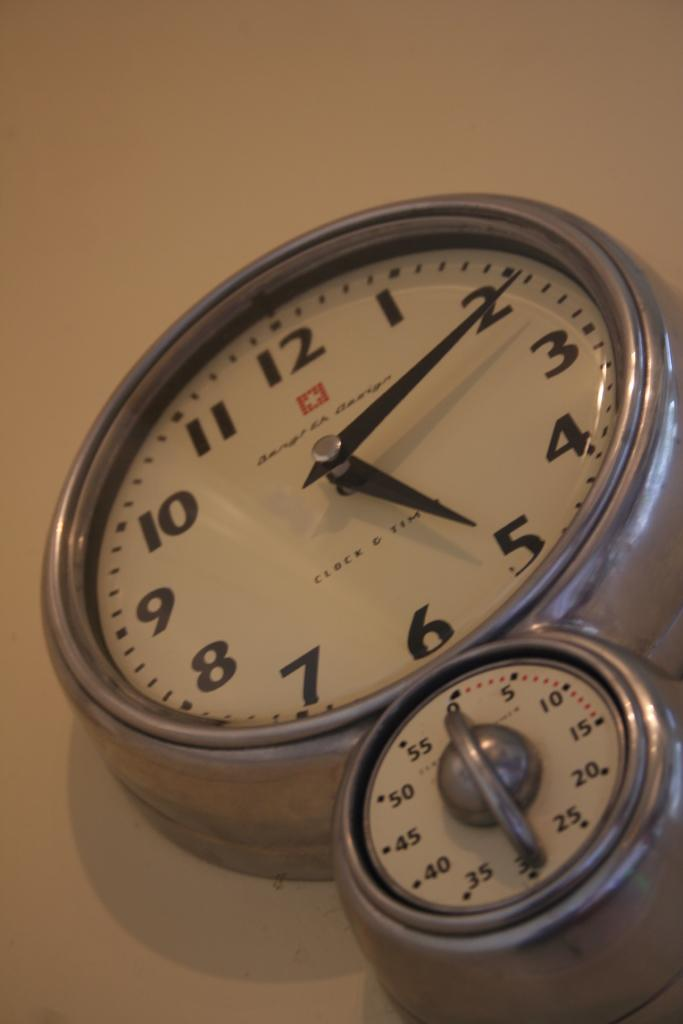<image>
Create a compact narrative representing the image presented. Clock which has the hands on the numbers 2 and 5 above a small timer. 